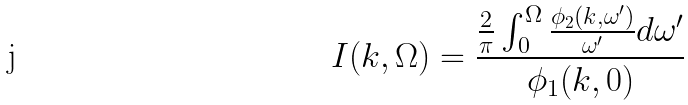Convert formula to latex. <formula><loc_0><loc_0><loc_500><loc_500>I ( k , \Omega ) = \frac { \frac { 2 } { \pi } \int ^ { \Omega } _ { 0 } \frac { \phi _ { 2 } ( k , \omega ^ { \prime } ) } { \omega ^ { \prime } } d \omega ^ { \prime } } { \phi _ { 1 } ( k , 0 ) }</formula> 